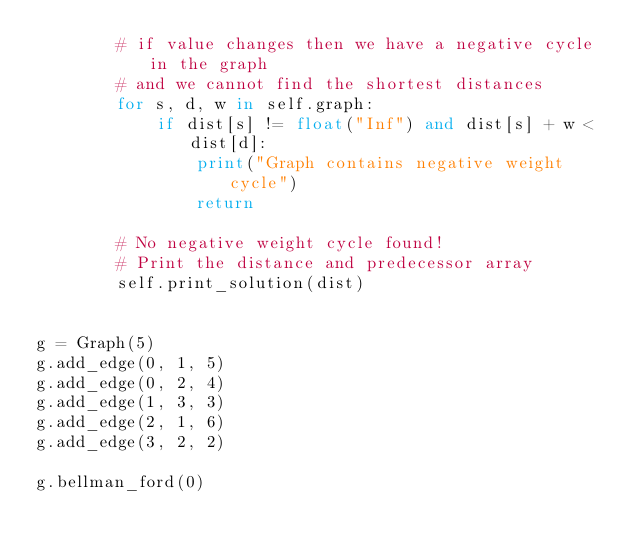<code> <loc_0><loc_0><loc_500><loc_500><_Python_>        # if value changes then we have a negative cycle in the graph
        # and we cannot find the shortest distances
        for s, d, w in self.graph:
            if dist[s] != float("Inf") and dist[s] + w < dist[d]:
                print("Graph contains negative weight cycle")
                return

        # No negative weight cycle found!
        # Print the distance and predecessor array
        self.print_solution(dist)


g = Graph(5)
g.add_edge(0, 1, 5)
g.add_edge(0, 2, 4)
g.add_edge(1, 3, 3)
g.add_edge(2, 1, 6)
g.add_edge(3, 2, 2)

g.bellman_ford(0)</code> 